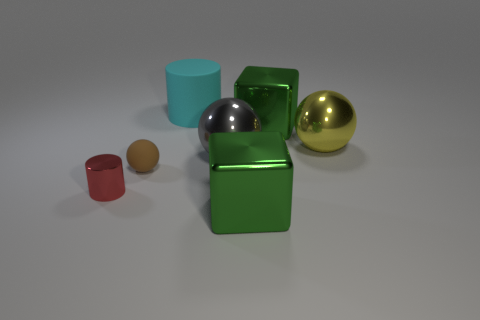What color is the sphere that is the same material as the large yellow object?
Give a very brief answer. Gray. What material is the big cyan object that is behind the gray metallic object?
Keep it short and to the point. Rubber. Are there the same number of shiny cubes that are left of the red thing and tiny purple matte cylinders?
Provide a succinct answer. Yes. How many small things have the same color as the metallic cylinder?
Offer a terse response. 0. What color is the other tiny metallic thing that is the same shape as the cyan object?
Keep it short and to the point. Red. Does the rubber ball have the same size as the yellow ball?
Your answer should be very brief. No. Is the number of big yellow shiny objects left of the cyan cylinder the same as the number of small red metal cylinders behind the tiny shiny cylinder?
Your answer should be compact. Yes. Is there a large yellow object?
Your response must be concise. Yes. There is a brown object that is the same shape as the large gray shiny thing; what size is it?
Offer a very short reply. Small. There is a metal sphere on the right side of the big gray ball; how big is it?
Your answer should be compact. Large. 